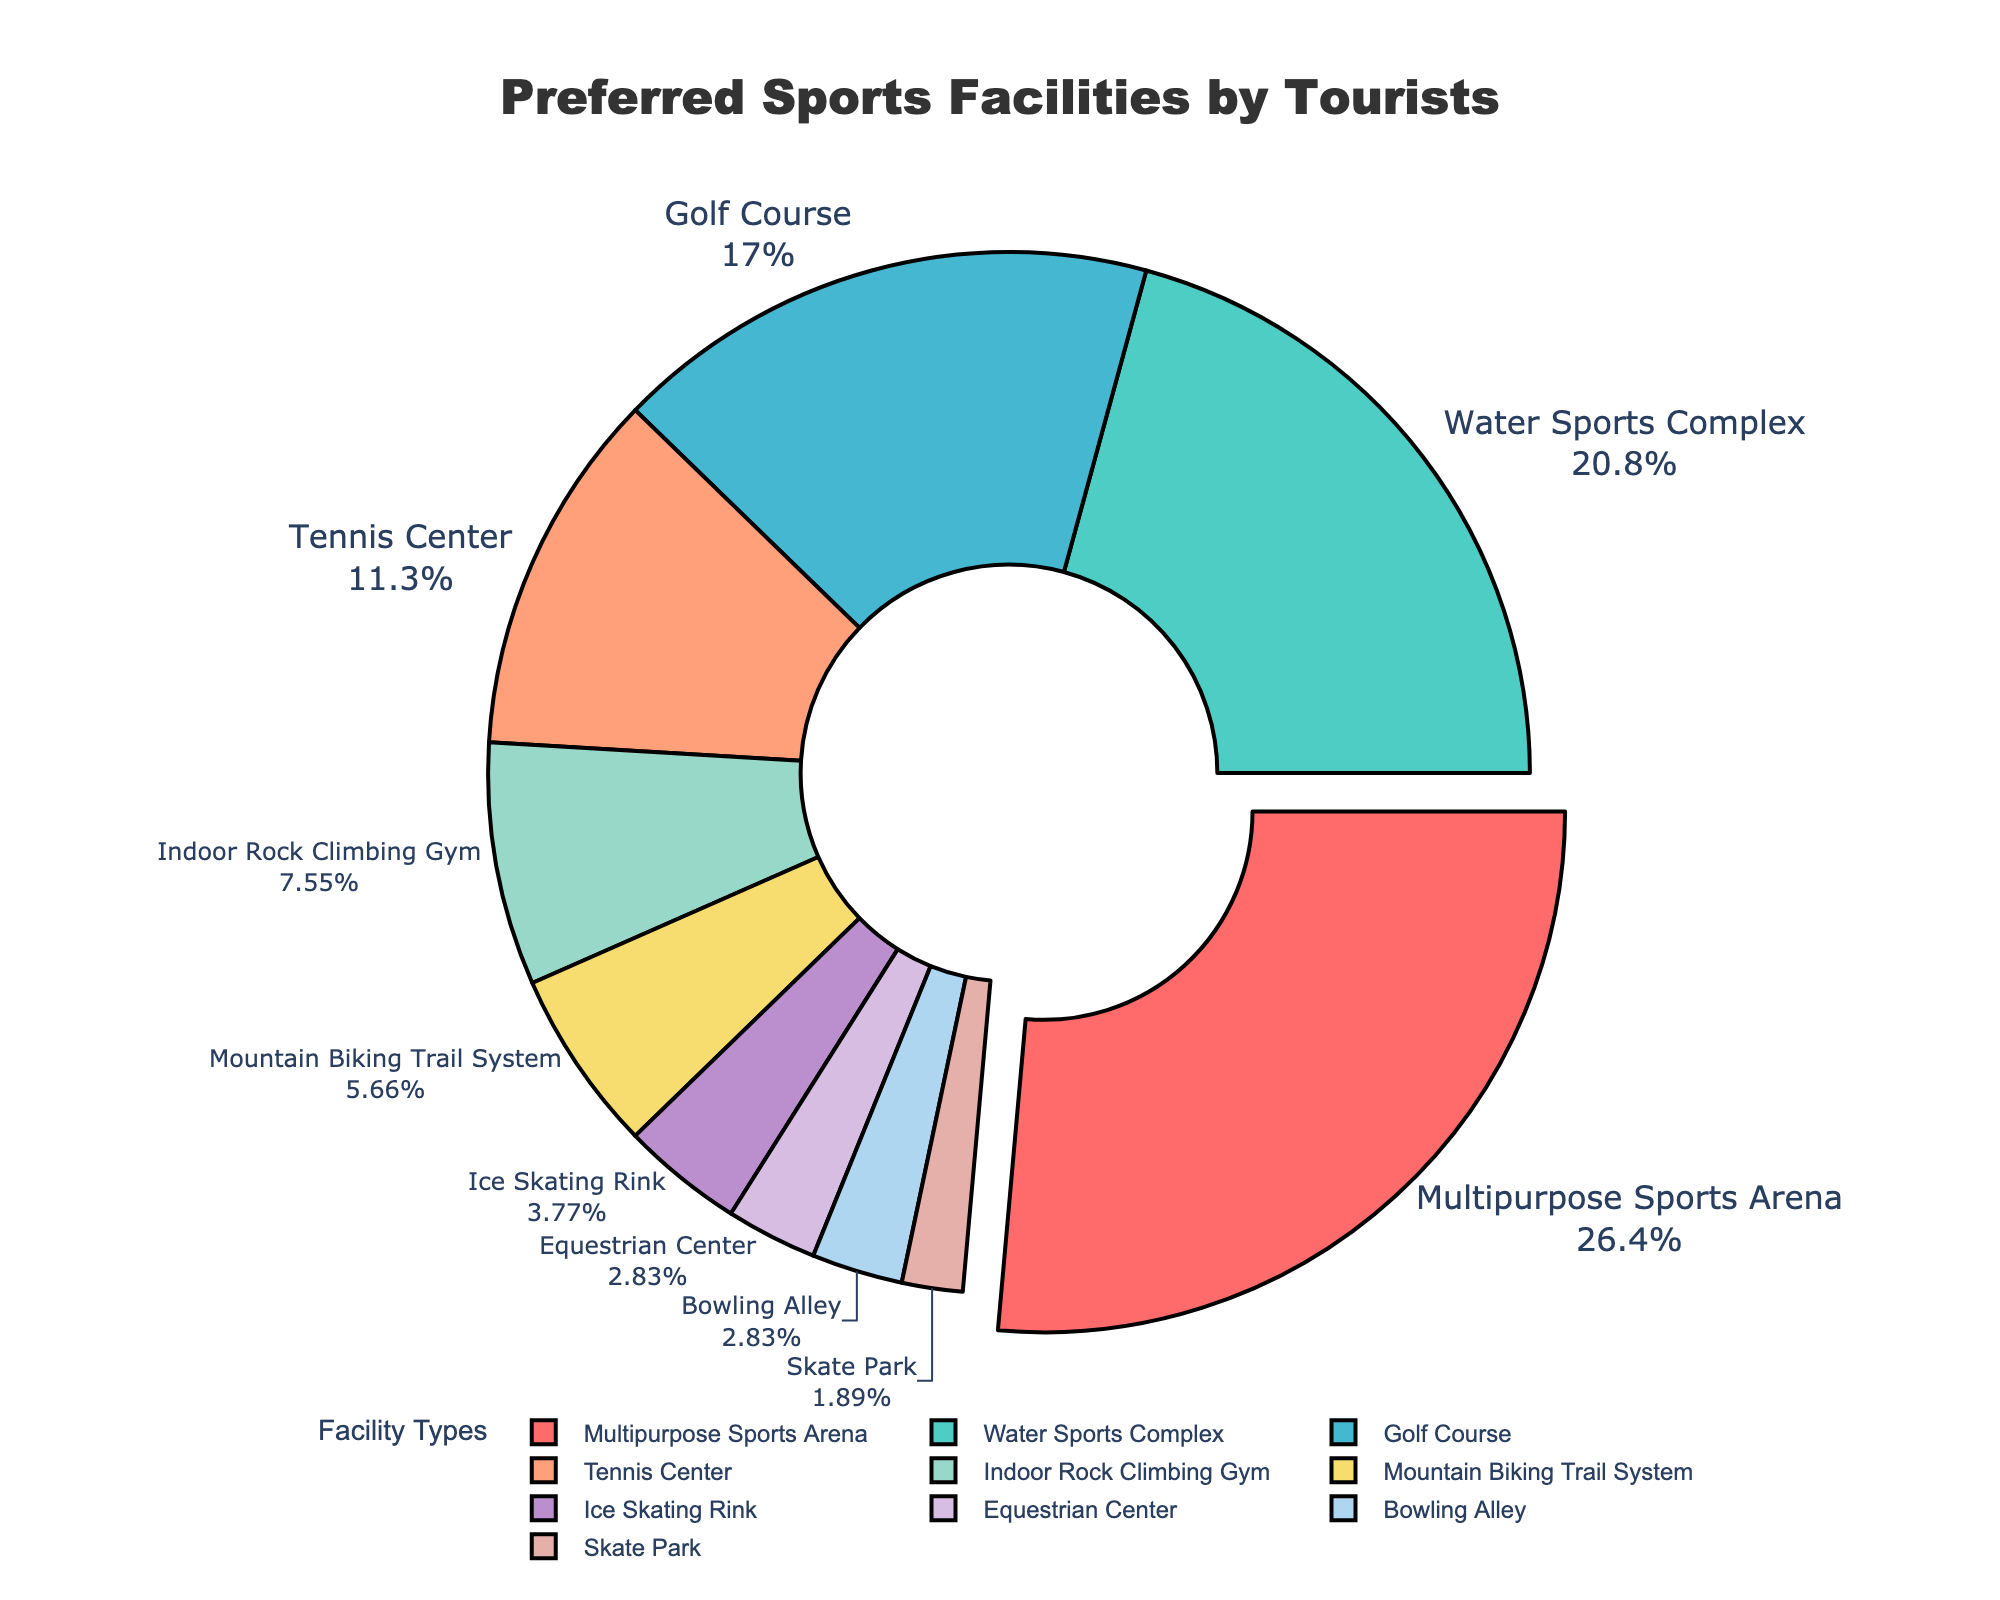What type of sports facility is the most popular among tourists? The most popular sports facility would be the one with the highest percentage in the pie chart. By identifying the segment with the largest percentage and possibly a slight pullout (due to the code), we can see that the Multipurpose Sports Arena has the highest percentage at 28%.
Answer: Multipurpose Sports Arena Which two types of sports facilities combined make up 30% of the popularity? To find this, we need to identify two segments whose combined percentages add up to 30%. The Indoor Rock Climbing Gym and Mountain Biking Trail System have percentages of 8% and 6%, respectively, which combined make 14%. The next closest pair is the Ice Skating Rink and Equestrian Center, which combined also make 7%. This adds up to 21%. By checking the segments with percentages that combine to make 30%, we find that the Tennis Center (12%) and Golf Course (18%) combined equal exactly 30%.
Answer: Tennis Center and Golf Course What is the combined popularity percentage of facilities related to water sports and ice skating? First, locate segments related to both water sports and ice skating. The Water Sports Complex has a percentage of 22%, and the Ice Skating Rink has 4%. Adding these two values together, we get 22% + 4% = 26%.
Answer: 26% Which facility is least popular among tourists, and how does its popularity compare to the second least popular facility? The least popular facility is identified by finding the smallest segment in the pie chart. The Skate Park is the least popular at 2%. The second least popular facility is the Equestrian Center and Bowling Alley, each at 3%. Consequently, the Skate Park's popularity is 1% less than that of the Equestrian Center or Bowling Alley.
Answer: Skate Park, 1% less List the sports facilities that have a popularity percentage greater than 15% but less than 25%. From the pie chart, identify segments within the given percentage range: greater than 15% but less than 25%. The Water Sports Complex (22%) and Golf Course (18%) fall within this range.
Answer: Water Sports Complex and Golf Course Which color represents the Golf Course in the pie chart? Each segment is colored differently. We find the segment labeled "Golf Course," which is likely colored in a visually distinguishable way. The set of custom colors suggests the Golf Course is colored in a specific shade. However, without needing to go into color specifics based on the code, it's directly labeled in the provided pie chart.
Answer: (Note: The color would be determined visually and answered accordingly.) Among Mountain Biking Trail System, Ice Skating Rink, and Bowling Alley, which one has the highest popularity percentage? By comparing the percentages directly on the pie chart, we can see: Mountain Biking Trail System has 6%, the Ice Skating Rink has 4%, and the Bowling Alley has 3%. Therefore, Mountain Biking Trail System has the highest popularity percentage among the three.
Answer: Mountain Biking Trail System 